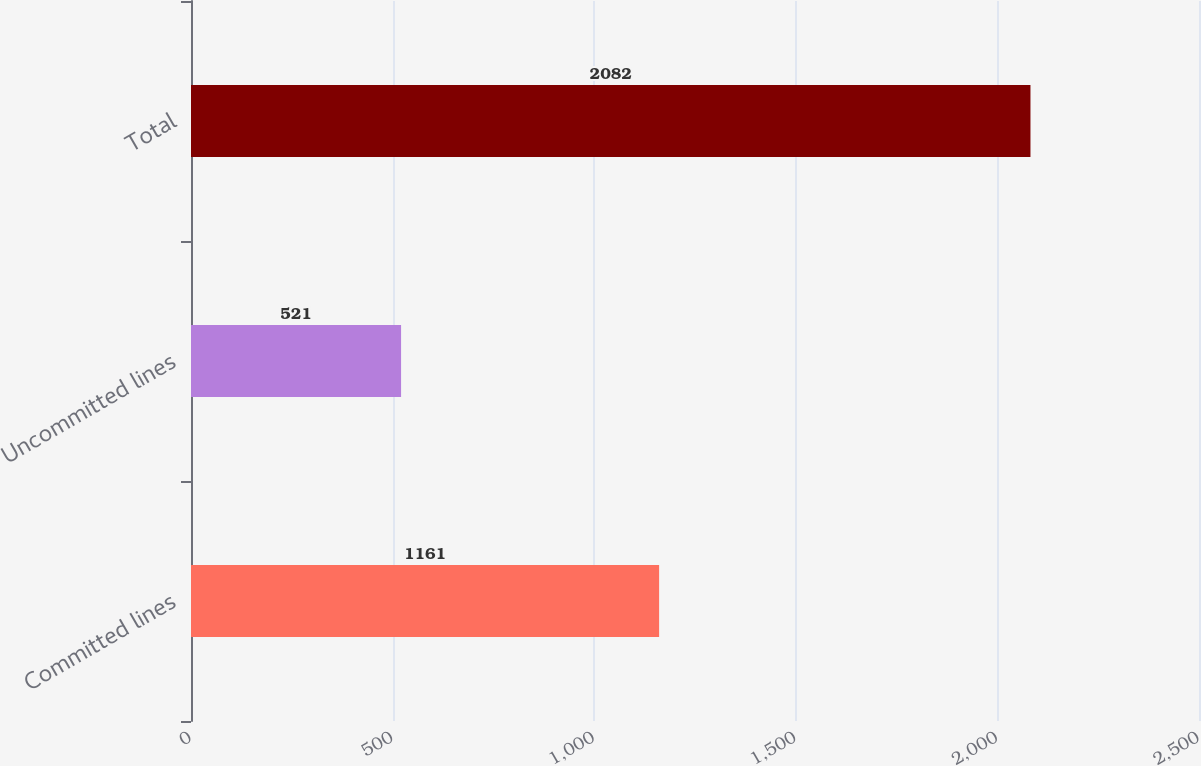<chart> <loc_0><loc_0><loc_500><loc_500><bar_chart><fcel>Committed lines<fcel>Uncommitted lines<fcel>Total<nl><fcel>1161<fcel>521<fcel>2082<nl></chart> 